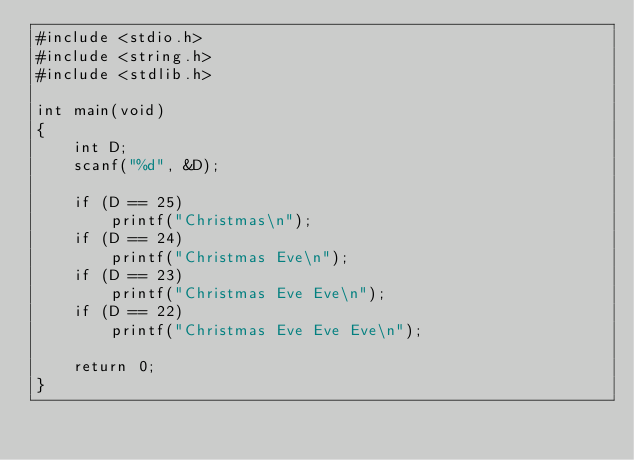Convert code to text. <code><loc_0><loc_0><loc_500><loc_500><_C_>#include <stdio.h>
#include <string.h>
#include <stdlib.h>

int main(void)
{
    int D;
    scanf("%d", &D);

    if (D == 25)
        printf("Christmas\n");
    if (D == 24)
        printf("Christmas Eve\n");
    if (D == 23)
        printf("Christmas Eve Eve\n");
    if (D == 22)
        printf("Christmas Eve Eve Eve\n");

    return 0;
}</code> 